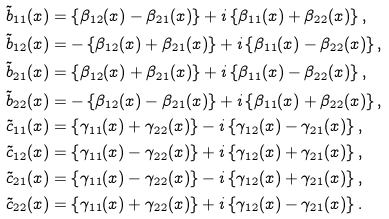<formula> <loc_0><loc_0><loc_500><loc_500>\tilde { b } _ { 1 1 } ( x ) & = \left \{ \beta _ { 1 2 } ( x ) - \beta _ { 2 1 } ( x ) \right \} + i \left \{ \beta _ { 1 1 } ( x ) + \beta _ { 2 2 } ( x ) \right \} , \\ \tilde { b } _ { 1 2 } ( x ) & = - \left \{ \beta _ { 1 2 } ( x ) + \beta _ { 2 1 } ( x ) \right \} + i \left \{ \beta _ { 1 1 } ( x ) - \beta _ { 2 2 } ( x ) \right \} , \\ \tilde { b } _ { 2 1 } ( x ) & = \left \{ \beta _ { 1 2 } ( x ) + \beta _ { 2 1 } ( x ) \right \} + i \left \{ \beta _ { 1 1 } ( x ) - \beta _ { 2 2 } ( x ) \right \} , \\ \tilde { b } _ { 2 2 } ( x ) & = - \left \{ \beta _ { 1 2 } ( x ) - \beta _ { 2 1 } ( x ) \right \} + i \left \{ \beta _ { 1 1 } ( x ) + \beta _ { 2 2 } ( x ) \right \} , \\ \tilde { c } _ { 1 1 } ( x ) & = \left \{ \gamma _ { 1 1 } ( x ) + \gamma _ { 2 2 } ( x ) \right \} - i \left \{ \gamma _ { 1 2 } ( x ) - \gamma _ { 2 1 } ( x ) \right \} , \\ \tilde { c } _ { 1 2 } ( x ) & = \left \{ \gamma _ { 1 1 } ( x ) - \gamma _ { 2 2 } ( x ) \right \} + i \left \{ \gamma _ { 1 2 } ( x ) + \gamma _ { 2 1 } ( x ) \right \} , \\ \tilde { c } _ { 2 1 } ( x ) & = \left \{ \gamma _ { 1 1 } ( x ) - \gamma _ { 2 2 } ( x ) \right \} - i \left \{ \gamma _ { 1 2 } ( x ) + \gamma _ { 2 1 } ( x ) \right \} , \\ \tilde { c } _ { 2 2 } ( x ) & = \left \{ \gamma _ { 1 1 } ( x ) + \gamma _ { 2 2 } ( x ) \right \} + i \left \{ \gamma _ { 1 2 } ( x ) - \gamma _ { 2 1 } ( x ) \right \} .</formula> 